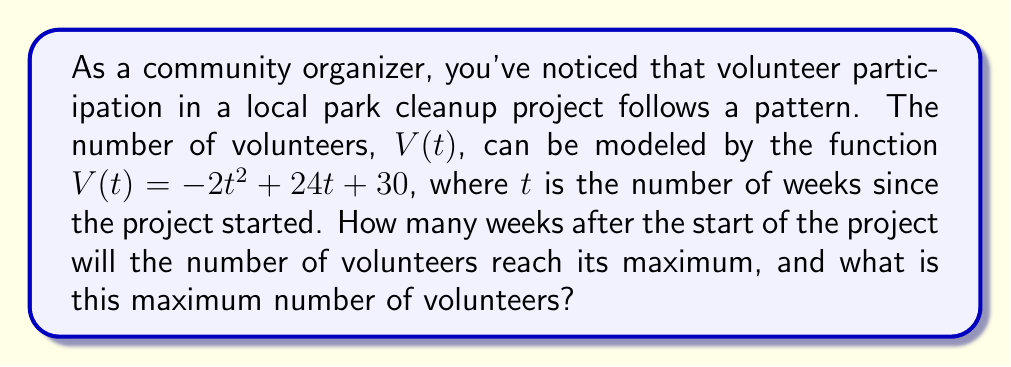Help me with this question. 1. The function $V(t) = -2t^2 + 24t + 30$ is a quadratic function.

2. For a quadratic function in the form $f(t) = at^2 + bt + c$, the t-coordinate of the vertex (which gives the maximum or minimum point) is given by $t = -\frac{b}{2a}$.

3. In this case, $a = -2$ and $b = 24$. Let's calculate the t-coordinate:

   $t = -\frac{24}{2(-2)} = -\frac{24}{-4} = 6$

4. This means the maximum number of volunteers occurs 6 weeks after the start of the project.

5. To find the maximum number of volunteers, we substitute $t = 6$ into the original function:

   $V(6) = -2(6)^2 + 24(6) + 30$
   $= -2(36) + 144 + 30$
   $= -72 + 144 + 30$
   $= 102$

Therefore, the maximum number of volunteers is 102, occurring 6 weeks after the start of the project.
Answer: 6 weeks; 102 volunteers 